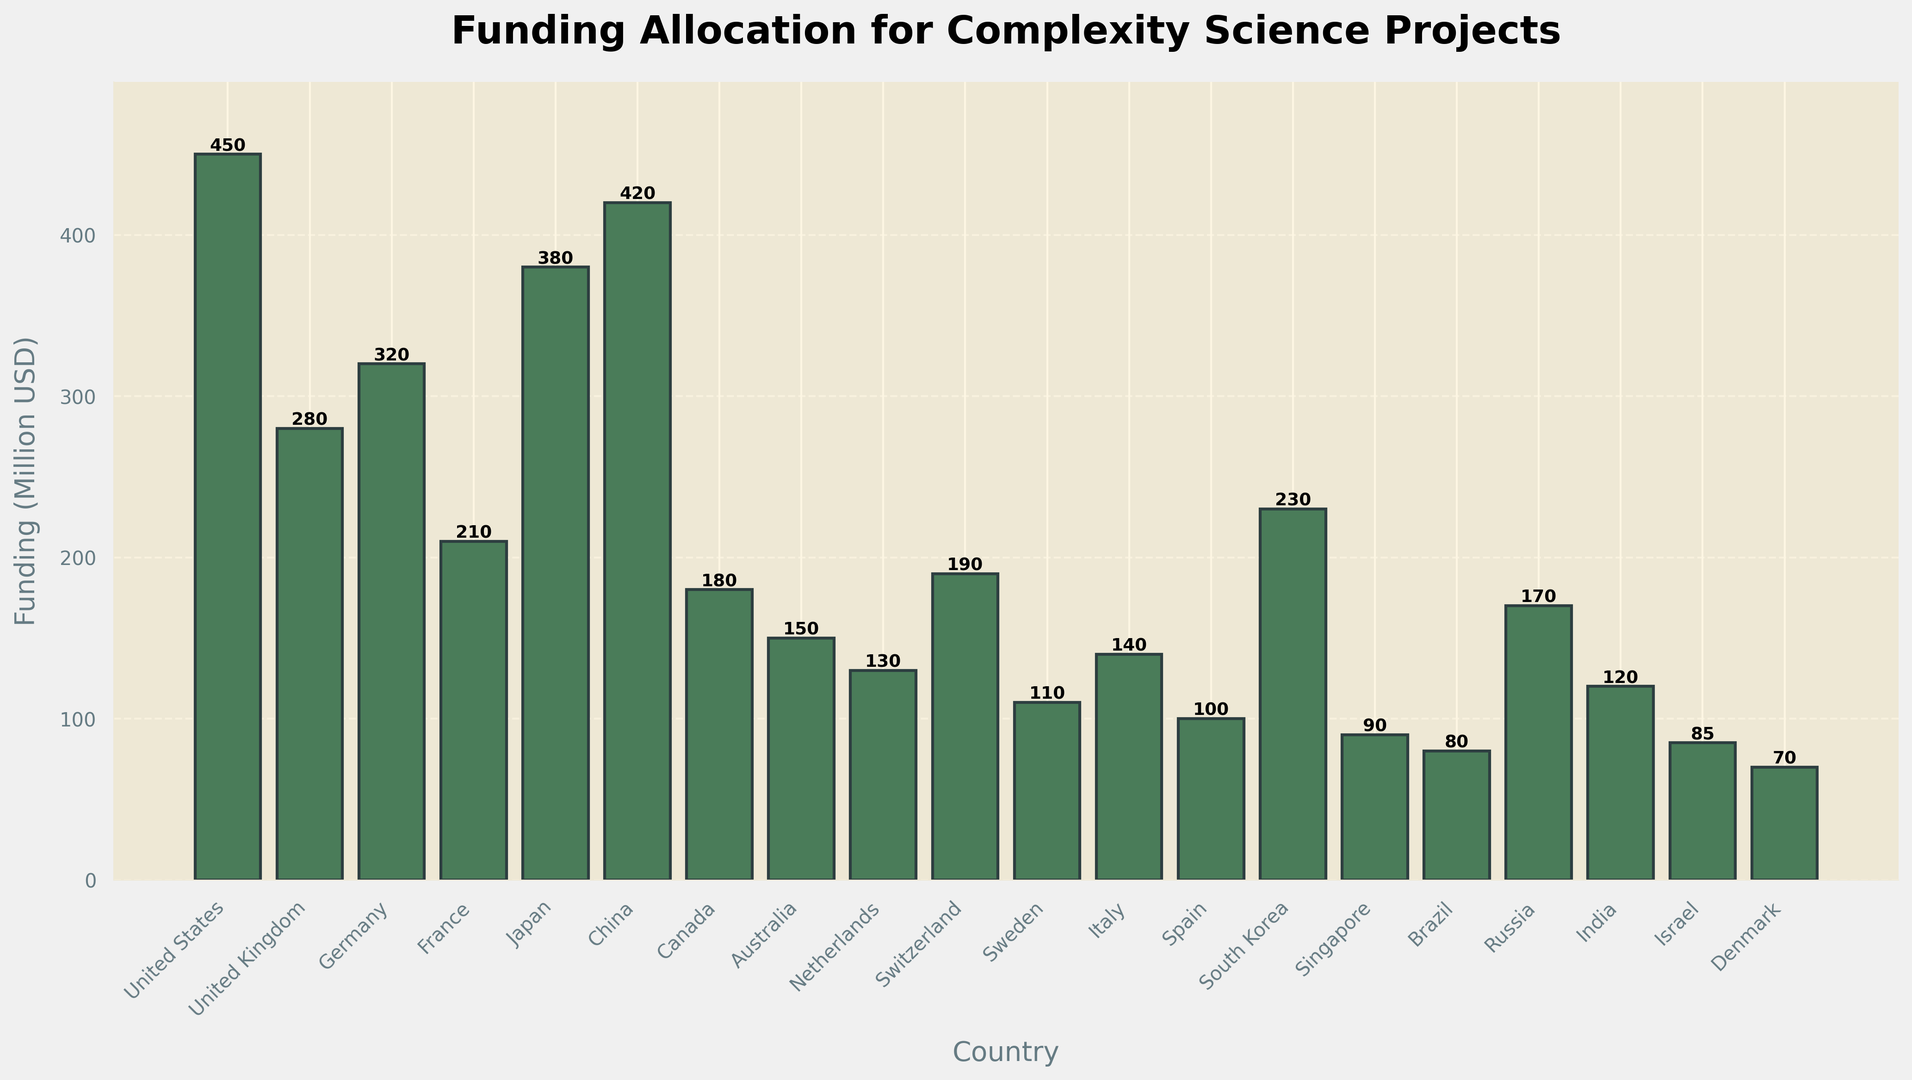What is the total funding allocated to European countries in this chart? First, identify the European countries listed: United Kingdom, Germany, France, Netherlands, Switzerland, Sweden, Italy, and Spain. Next, sum their funding: UK (280) + Germany (320) + France (210) + Netherlands (130) + Switzerland (190) + Sweden (110) + Italy (140) + Spain (100) = 1480 million USD
Answer: 1480 million USD Which country has the highest funding, and how much is it? Compare the funding allocations for each country to find the highest. The United States has the highest funding with 450 million USD
Answer: United States, 450 million USD How does the funding for China compare to that of Japan? Check the funding amounts: China has 420 million USD and Japan has 380 million USD. Therefore, China's funding is higher
Answer: China’s funding is higher by 40 million USD What is the average funding amount across all countries listed? Sum the funding of all countries and divide by the number of countries: (450 + 280 + 320 + 210 + 380 + 420 + 180 + 150 + 130 + 190 + 110 + 140 + 100 + 230 + 90 + 80 + 170 + 120 + 85 + 70) / 20 = 4,305 / 20 = 215.25 million USD
Answer: 215.25 million USD Are there more countries with funding above or below 200 million USD? Count the number of countries with funding above and below 200 million USD: Above - United States (450), United Kingdom (280), Germany (320), Japan (380), China (420), South Korea (230); Below - France (210), Canada (180), Australia (150), Netherlands (130), Switzerland (190), Sweden (110), Italy (140), Spain (100), Singapore (90), Brazil (80), Russia (170), India (120), Israel (85), Denmark (70). Above: 6 countries, Below: 14 countries
Answer: More countries have funding below 200 million USD Which country’s funding is closest to the average funding amount, and what is that amount? The average funding amount is 215.25 million USD. Find the closest country by calculating the absolute difference: United Kingdom (280), Germany (320), France (210), Japan (380), China (420), South Korea (230), and others. The closest funding amount is France with 210 million USD, having a difference of 5.25 million USD from the average
Answer: France, 210 million USD 